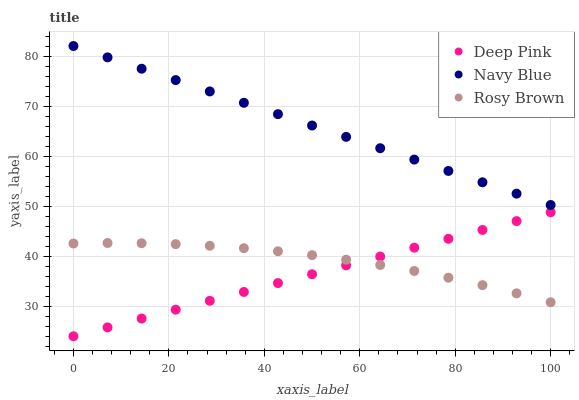Does Deep Pink have the minimum area under the curve?
Answer yes or no. Yes. Does Navy Blue have the maximum area under the curve?
Answer yes or no. Yes. Does Rosy Brown have the minimum area under the curve?
Answer yes or no. No. Does Rosy Brown have the maximum area under the curve?
Answer yes or no. No. Is Navy Blue the smoothest?
Answer yes or no. Yes. Is Rosy Brown the roughest?
Answer yes or no. Yes. Is Deep Pink the smoothest?
Answer yes or no. No. Is Deep Pink the roughest?
Answer yes or no. No. Does Deep Pink have the lowest value?
Answer yes or no. Yes. Does Rosy Brown have the lowest value?
Answer yes or no. No. Does Navy Blue have the highest value?
Answer yes or no. Yes. Does Deep Pink have the highest value?
Answer yes or no. No. Is Deep Pink less than Navy Blue?
Answer yes or no. Yes. Is Navy Blue greater than Rosy Brown?
Answer yes or no. Yes. Does Rosy Brown intersect Deep Pink?
Answer yes or no. Yes. Is Rosy Brown less than Deep Pink?
Answer yes or no. No. Is Rosy Brown greater than Deep Pink?
Answer yes or no. No. Does Deep Pink intersect Navy Blue?
Answer yes or no. No. 